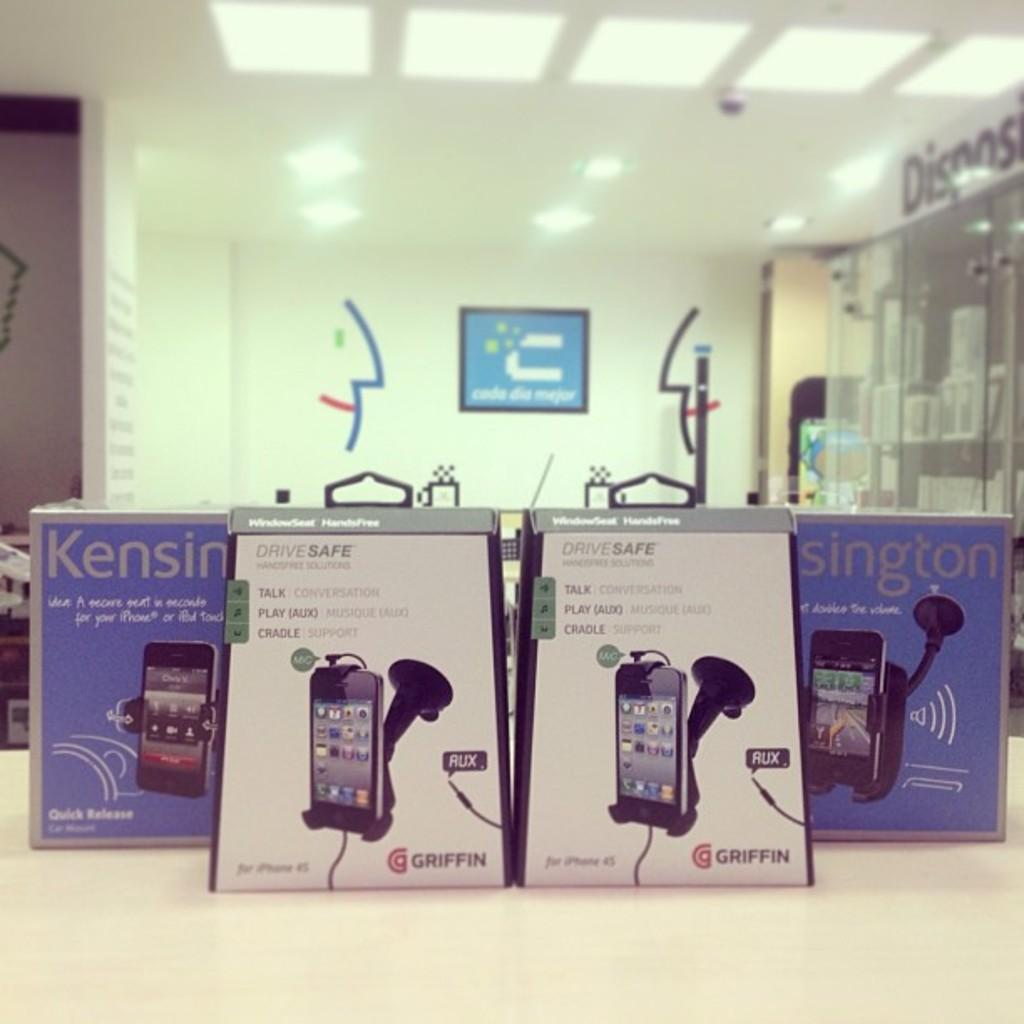<image>
Offer a succinct explanation of the picture presented. a blue box with Kensington written on it 